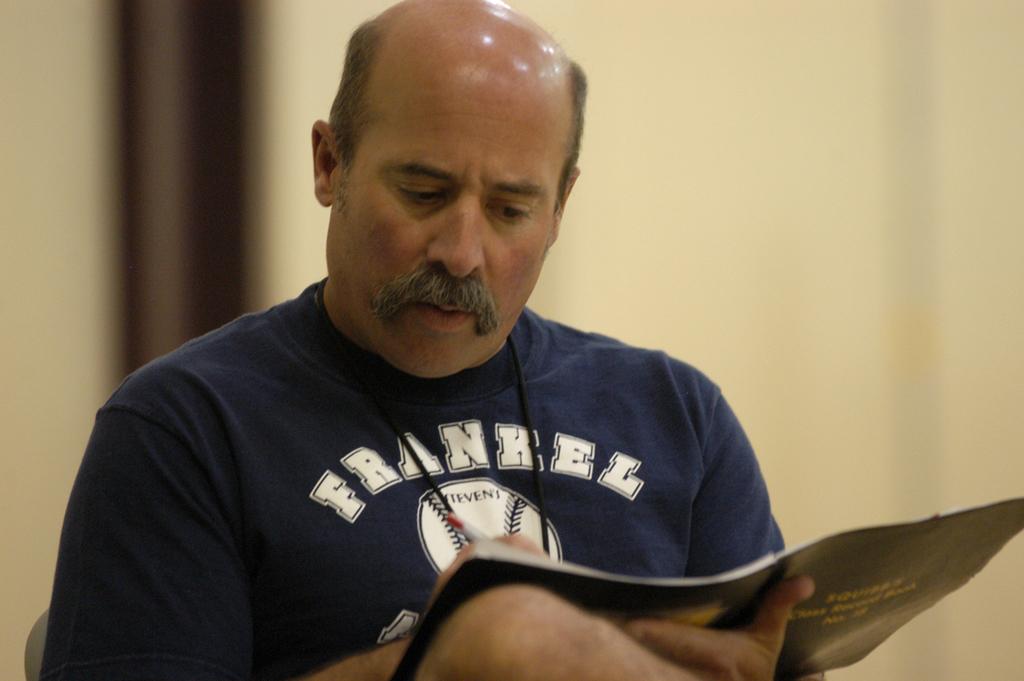What is written on the baseball?
Offer a terse response. Steven's. 